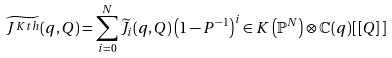<formula> <loc_0><loc_0><loc_500><loc_500>\widetilde { J ^ { K t h } } ( q , Q ) = \sum _ { i = 0 } ^ { N } \widetilde { J _ { i } } ( q , Q ) \left ( 1 - P ^ { - 1 } \right ) ^ { i } \in K \left ( \mathbb { P } ^ { N } \right ) \otimes \mathbb { C } ( q ) [ \, [ Q ] \, ]</formula> 